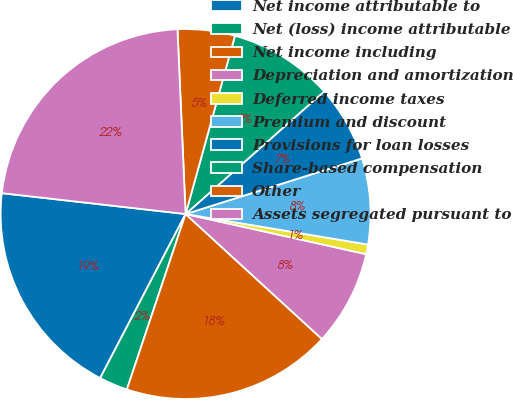Convert chart to OTSL. <chart><loc_0><loc_0><loc_500><loc_500><pie_chart><fcel>Net income attributable to<fcel>Net (loss) income attributable<fcel>Net income including<fcel>Depreciation and amortization<fcel>Deferred income taxes<fcel>Premium and discount<fcel>Provisions for loan losses<fcel>Share-based compensation<fcel>Other<fcel>Assets segregated pursuant to<nl><fcel>19.16%<fcel>2.5%<fcel>18.33%<fcel>8.33%<fcel>0.84%<fcel>7.5%<fcel>6.67%<fcel>9.17%<fcel>5.0%<fcel>22.5%<nl></chart> 